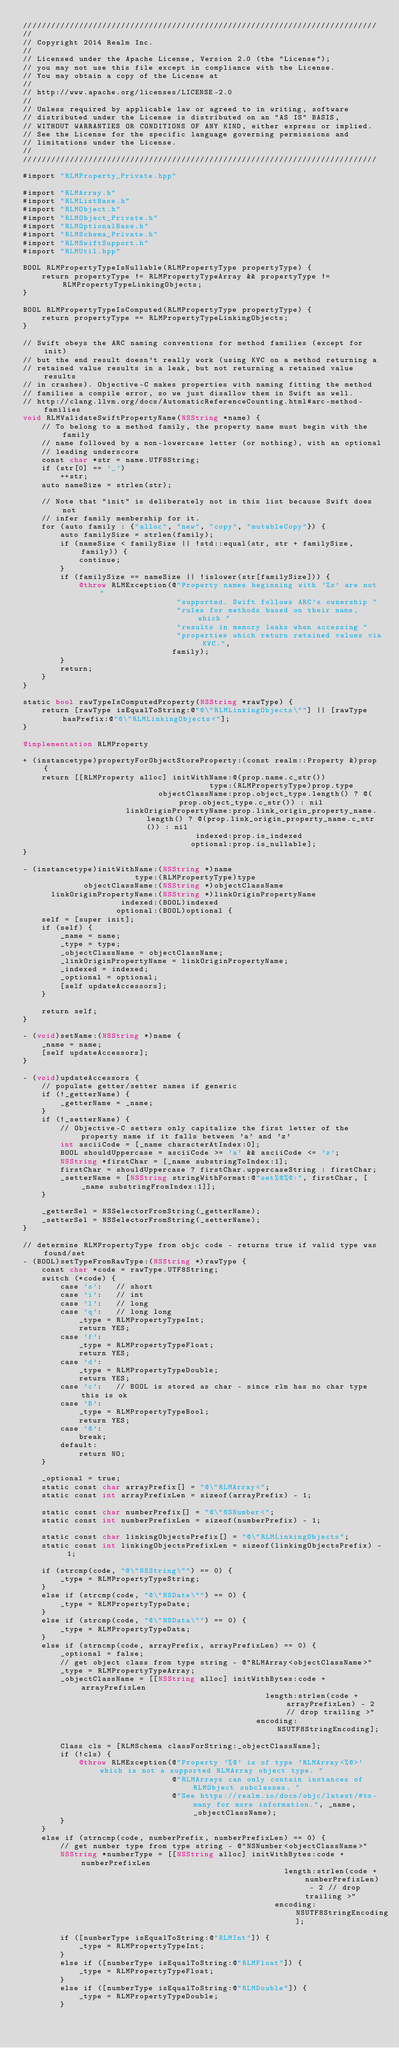Convert code to text. <code><loc_0><loc_0><loc_500><loc_500><_ObjectiveC_>////////////////////////////////////////////////////////////////////////////
//
// Copyright 2014 Realm Inc.
//
// Licensed under the Apache License, Version 2.0 (the "License");
// you may not use this file except in compliance with the License.
// You may obtain a copy of the License at
//
// http://www.apache.org/licenses/LICENSE-2.0
//
// Unless required by applicable law or agreed to in writing, software
// distributed under the License is distributed on an "AS IS" BASIS,
// WITHOUT WARRANTIES OR CONDITIONS OF ANY KIND, either express or implied.
// See the License for the specific language governing permissions and
// limitations under the License.
//
////////////////////////////////////////////////////////////////////////////

#import "RLMProperty_Private.hpp"

#import "RLMArray.h"
#import "RLMListBase.h"
#import "RLMObject.h"
#import "RLMObject_Private.h"
#import "RLMOptionalBase.h"
#import "RLMSchema_Private.h"
#import "RLMSwiftSupport.h"
#import "RLMUtil.hpp"

BOOL RLMPropertyTypeIsNullable(RLMPropertyType propertyType) {
    return propertyType != RLMPropertyTypeArray && propertyType != RLMPropertyTypeLinkingObjects;
}

BOOL RLMPropertyTypeIsComputed(RLMPropertyType propertyType) {
    return propertyType == RLMPropertyTypeLinkingObjects;
}

// Swift obeys the ARC naming conventions for method families (except for init)
// but the end result doesn't really work (using KVC on a method returning a
// retained value results in a leak, but not returning a retained value results
// in crashes). Objective-C makes properties with naming fitting the method
// families a compile error, so we just disallow them in Swift as well.
// http://clang.llvm.org/docs/AutomaticReferenceCounting.html#arc-method-families
void RLMValidateSwiftPropertyName(NSString *name) {
    // To belong to a method family, the property name must begin with the family
    // name followed by a non-lowercase letter (or nothing), with an optional
    // leading underscore
    const char *str = name.UTF8String;
    if (str[0] == '_')
        ++str;
    auto nameSize = strlen(str);

    // Note that "init" is deliberately not in this list because Swift does not
    // infer family membership for it.
    for (auto family : {"alloc", "new", "copy", "mutableCopy"}) {
        auto familySize = strlen(family);
        if (nameSize < familySize || !std::equal(str, str + familySize, family)) {
            continue;
        }
        if (familySize == nameSize || !islower(str[familySize])) {
            @throw RLMException(@"Property names beginning with '%s' are not "
                                 "supported. Swift follows ARC's ownership "
                                 "rules for methods based on their name, which "
                                 "results in memory leaks when accessing "
                                 "properties which return retained values via KVC.",
                                family);
        }
        return;
    }
}

static bool rawTypeIsComputedProperty(NSString *rawType) {
    return [rawType isEqualToString:@"@\"RLMLinkingObjects\""] || [rawType hasPrefix:@"@\"RLMLinkingObjects<"];
}

@implementation RLMProperty

+ (instancetype)propertyForObjectStoreProperty:(const realm::Property &)prop {
    return [[RLMProperty alloc] initWithName:@(prop.name.c_str())
                                        type:(RLMPropertyType)prop.type
                             objectClassName:prop.object_type.length() ? @(prop.object_type.c_str()) : nil
                      linkOriginPropertyName:prop.link_origin_property_name.length() ? @(prop.link_origin_property_name.c_str()) : nil
                                     indexed:prop.is_indexed
                                    optional:prop.is_nullable];
}

- (instancetype)initWithName:(NSString *)name
                        type:(RLMPropertyType)type
             objectClassName:(NSString *)objectClassName
      linkOriginPropertyName:(NSString *)linkOriginPropertyName
                     indexed:(BOOL)indexed
                    optional:(BOOL)optional {
    self = [super init];
    if (self) {
        _name = name;
        _type = type;
        _objectClassName = objectClassName;
        _linkOriginPropertyName = linkOriginPropertyName;
        _indexed = indexed;
        _optional = optional;
        [self updateAccessors];
    }

    return self;
}

- (void)setName:(NSString *)name {
    _name = name;
    [self updateAccessors];
}

- (void)updateAccessors {
    // populate getter/setter names if generic
    if (!_getterName) {
        _getterName = _name;
    }
    if (!_setterName) {
        // Objective-C setters only capitalize the first letter of the property name if it falls between 'a' and 'z'
        int asciiCode = [_name characterAtIndex:0];
        BOOL shouldUppercase = asciiCode >= 'a' && asciiCode <= 'z';
        NSString *firstChar = [_name substringToIndex:1];
        firstChar = shouldUppercase ? firstChar.uppercaseString : firstChar;
        _setterName = [NSString stringWithFormat:@"set%@%@:", firstChar, [_name substringFromIndex:1]];
    }

    _getterSel = NSSelectorFromString(_getterName);
    _setterSel = NSSelectorFromString(_setterName);
}

// determine RLMPropertyType from objc code - returns true if valid type was found/set
- (BOOL)setTypeFromRawType:(NSString *)rawType {
    const char *code = rawType.UTF8String;
    switch (*code) {
        case 's':   // short
        case 'i':   // int
        case 'l':   // long
        case 'q':   // long long
            _type = RLMPropertyTypeInt;
            return YES;
        case 'f':
            _type = RLMPropertyTypeFloat;
            return YES;
        case 'd':
            _type = RLMPropertyTypeDouble;
            return YES;
        case 'c':   // BOOL is stored as char - since rlm has no char type this is ok
        case 'B':
            _type = RLMPropertyTypeBool;
            return YES;
        case '@':
            break;
        default:
            return NO;
    }

    _optional = true;
    static const char arrayPrefix[] = "@\"RLMArray<";
    static const int arrayPrefixLen = sizeof(arrayPrefix) - 1;

    static const char numberPrefix[] = "@\"NSNumber<";
    static const int numberPrefixLen = sizeof(numberPrefix) - 1;

    static const char linkingObjectsPrefix[] = "@\"RLMLinkingObjects";
    static const int linkingObjectsPrefixLen = sizeof(linkingObjectsPrefix) - 1;

    if (strcmp(code, "@\"NSString\"") == 0) {
        _type = RLMPropertyTypeString;
    }
    else if (strcmp(code, "@\"NSDate\"") == 0) {
        _type = RLMPropertyTypeDate;
    }
    else if (strcmp(code, "@\"NSData\"") == 0) {
        _type = RLMPropertyTypeData;
    }
    else if (strncmp(code, arrayPrefix, arrayPrefixLen) == 0) {
        _optional = false;
        // get object class from type string - @"RLMArray<objectClassName>"
        _type = RLMPropertyTypeArray;
        _objectClassName = [[NSString alloc] initWithBytes:code + arrayPrefixLen
                                                    length:strlen(code + arrayPrefixLen) - 2 // drop trailing >"
                                                  encoding:NSUTF8StringEncoding];

        Class cls = [RLMSchema classForString:_objectClassName];
        if (!cls) {
            @throw RLMException(@"Property '%@' is of type 'RLMArray<%@>' which is not a supported RLMArray object type. "
                                @"RLMArrays can only contain instances of RLMObject subclasses. "
                                @"See https://realm.io/docs/objc/latest/#to-many for more information.", _name, _objectClassName);
        }
    }
    else if (strncmp(code, numberPrefix, numberPrefixLen) == 0) {
        // get number type from type string - @"NSNumber<objectClassName>"
        NSString *numberType = [[NSString alloc] initWithBytes:code + numberPrefixLen
                                                        length:strlen(code + numberPrefixLen) - 2 // drop trailing >"
                                                      encoding:NSUTF8StringEncoding];

        if ([numberType isEqualToString:@"RLMInt"]) {
            _type = RLMPropertyTypeInt;
        }
        else if ([numberType isEqualToString:@"RLMFloat"]) {
            _type = RLMPropertyTypeFloat;
        }
        else if ([numberType isEqualToString:@"RLMDouble"]) {
            _type = RLMPropertyTypeDouble;
        }</code> 